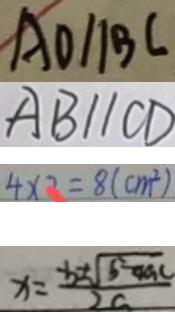<formula> <loc_0><loc_0><loc_500><loc_500>A O / / B C 
 A B / / C D 
 4 \times 2 = 8 ( c m ^ { 2 } ) 
 x = \frac { - b \pm \sqrt { b - 4 a c } } { 2 c }</formula> 